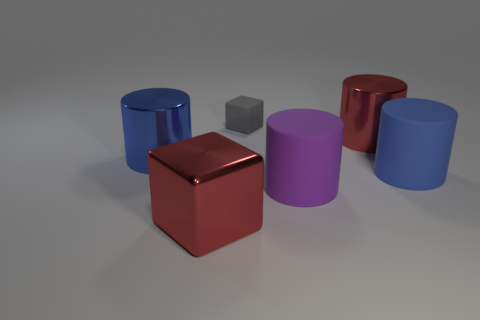Subtract all purple balls. How many blue cylinders are left? 2 Add 4 tiny gray objects. How many objects exist? 10 Subtract all purple matte cylinders. How many cylinders are left? 3 Subtract 2 cylinders. How many cylinders are left? 2 Subtract all purple cylinders. How many cylinders are left? 3 Add 3 large green shiny balls. How many large green shiny balls exist? 3 Subtract 0 brown cylinders. How many objects are left? 6 Subtract all cubes. How many objects are left? 4 Subtract all yellow cylinders. Subtract all purple cubes. How many cylinders are left? 4 Subtract all big purple objects. Subtract all large shiny things. How many objects are left? 2 